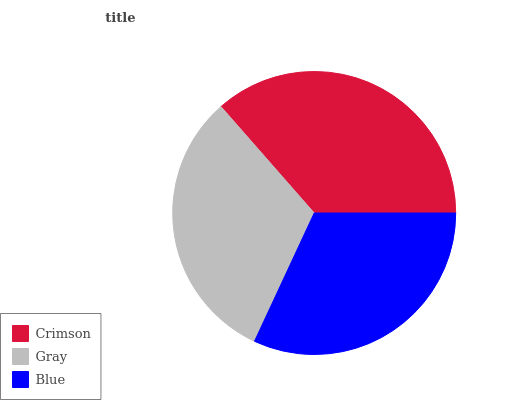Is Gray the minimum?
Answer yes or no. Yes. Is Crimson the maximum?
Answer yes or no. Yes. Is Blue the minimum?
Answer yes or no. No. Is Blue the maximum?
Answer yes or no. No. Is Blue greater than Gray?
Answer yes or no. Yes. Is Gray less than Blue?
Answer yes or no. Yes. Is Gray greater than Blue?
Answer yes or no. No. Is Blue less than Gray?
Answer yes or no. No. Is Blue the high median?
Answer yes or no. Yes. Is Blue the low median?
Answer yes or no. Yes. Is Gray the high median?
Answer yes or no. No. Is Crimson the low median?
Answer yes or no. No. 